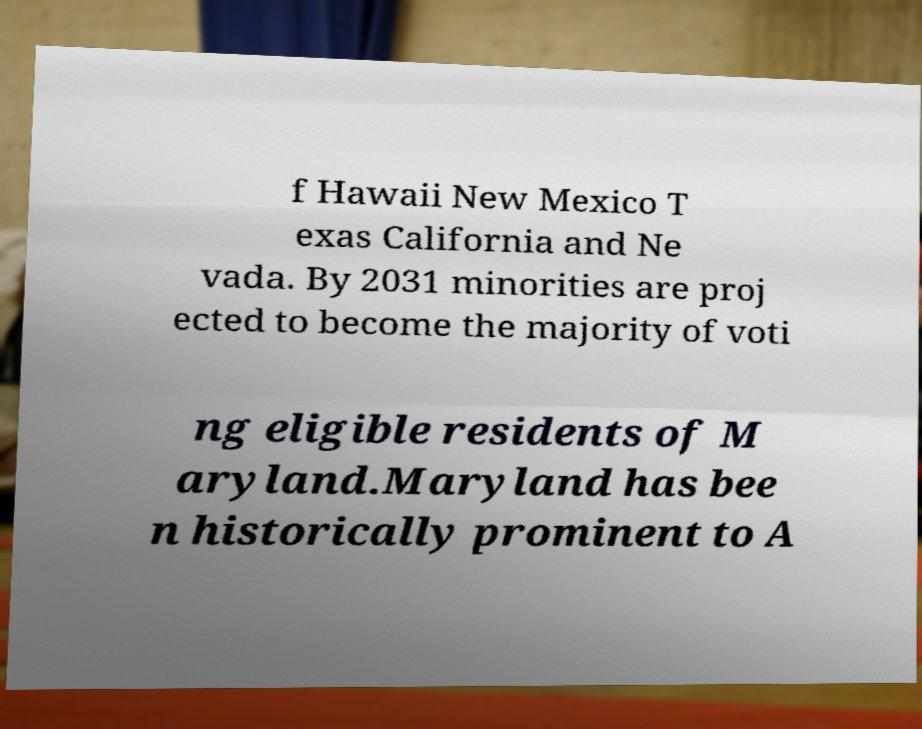There's text embedded in this image that I need extracted. Can you transcribe it verbatim? f Hawaii New Mexico T exas California and Ne vada. By 2031 minorities are proj ected to become the majority of voti ng eligible residents of M aryland.Maryland has bee n historically prominent to A 